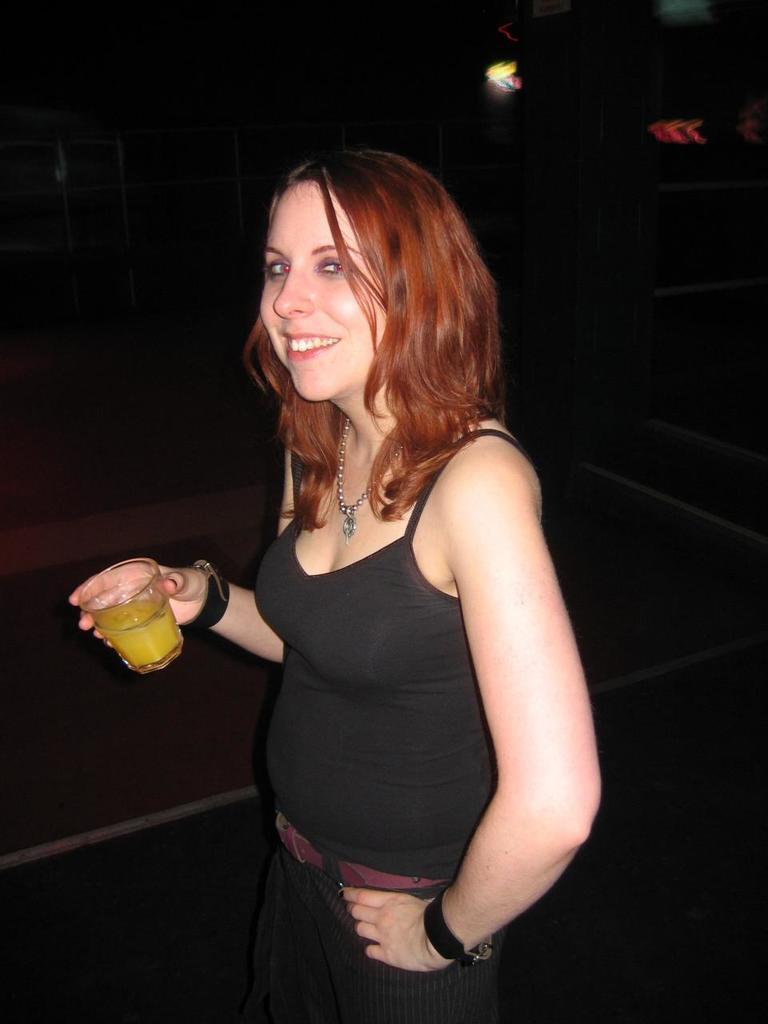Can you describe this image briefly? In this image I can see a woman wearing black dress is standing and holding a glass in her hand. I can see the black colored background. 